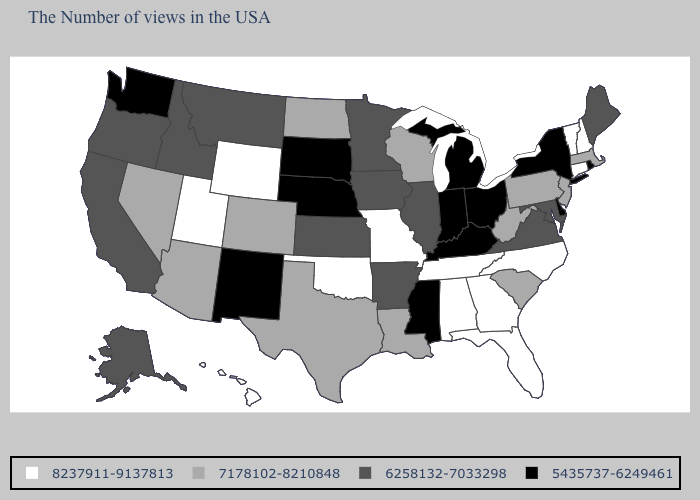Does New Mexico have a lower value than Minnesota?
Keep it brief. Yes. Does New Mexico have the lowest value in the West?
Be succinct. Yes. What is the value of Wyoming?
Short answer required. 8237911-9137813. Name the states that have a value in the range 6258132-7033298?
Short answer required. Maine, Maryland, Virginia, Illinois, Arkansas, Minnesota, Iowa, Kansas, Montana, Idaho, California, Oregon, Alaska. Which states hav the highest value in the South?
Short answer required. North Carolina, Florida, Georgia, Alabama, Tennessee, Oklahoma. Does New Hampshire have the highest value in the USA?
Answer briefly. Yes. Which states have the lowest value in the USA?
Answer briefly. Rhode Island, New York, Delaware, Ohio, Michigan, Kentucky, Indiana, Mississippi, Nebraska, South Dakota, New Mexico, Washington. Name the states that have a value in the range 7178102-8210848?
Quick response, please. Massachusetts, New Jersey, Pennsylvania, South Carolina, West Virginia, Wisconsin, Louisiana, Texas, North Dakota, Colorado, Arizona, Nevada. Among the states that border Delaware , does Pennsylvania have the highest value?
Concise answer only. Yes. What is the value of Massachusetts?
Give a very brief answer. 7178102-8210848. What is the value of California?
Answer briefly. 6258132-7033298. What is the value of North Dakota?
Concise answer only. 7178102-8210848. What is the highest value in the USA?
Short answer required. 8237911-9137813. Name the states that have a value in the range 7178102-8210848?
Concise answer only. Massachusetts, New Jersey, Pennsylvania, South Carolina, West Virginia, Wisconsin, Louisiana, Texas, North Dakota, Colorado, Arizona, Nevada. 